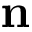<formula> <loc_0><loc_0><loc_500><loc_500>{ n }</formula> 